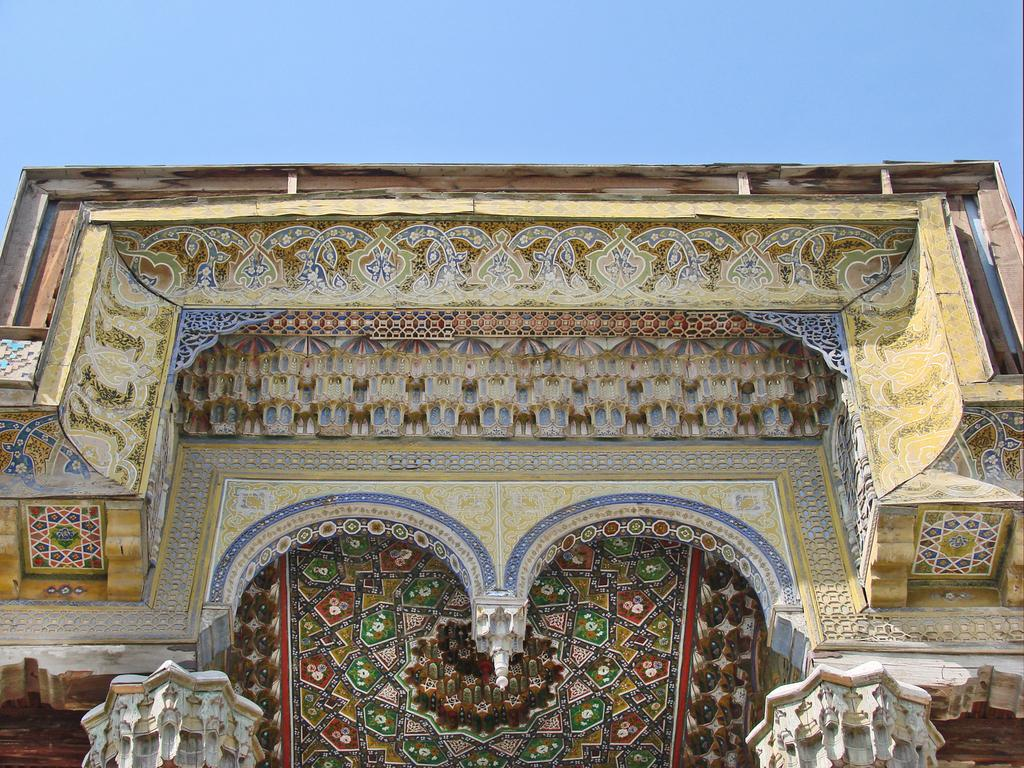What type of structure is featured in the image? There is a building with a design in the image. What can be seen in the background of the image? The sky is visible in the background of the image. How much coal is stored inside the building in the image? There is no information about coal or storage in the image; it only features a building with a design and the sky in the background. 